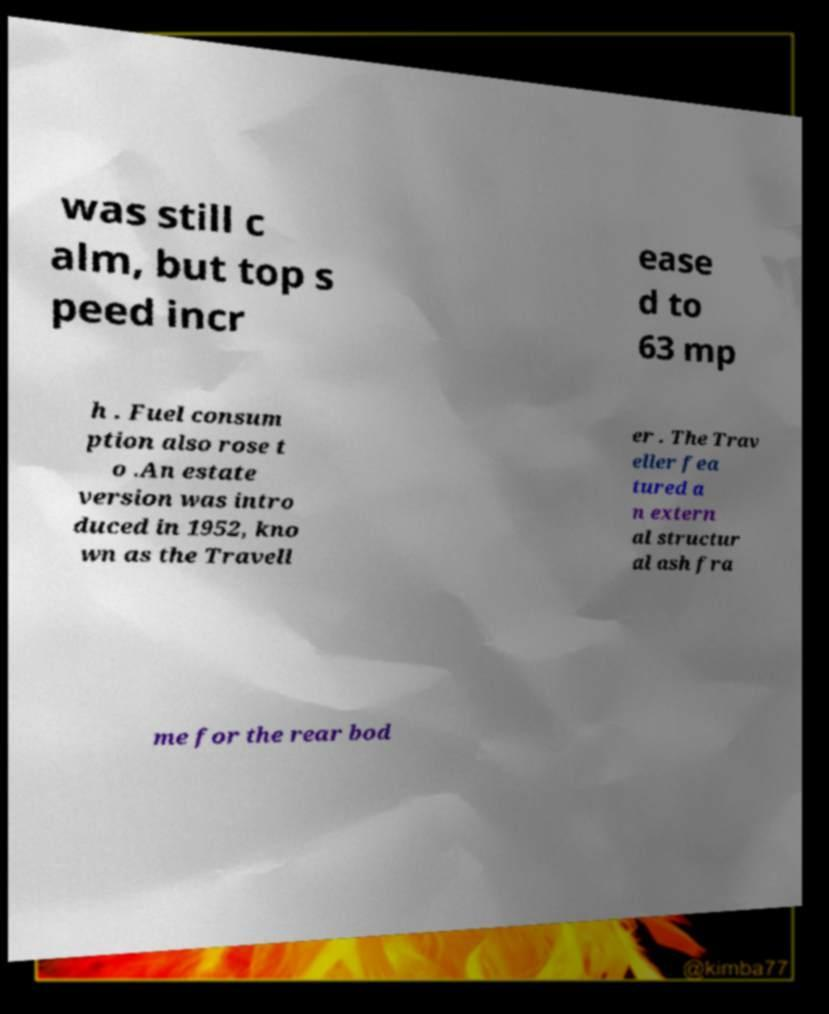Can you read and provide the text displayed in the image?This photo seems to have some interesting text. Can you extract and type it out for me? was still c alm, but top s peed incr ease d to 63 mp h . Fuel consum ption also rose t o .An estate version was intro duced in 1952, kno wn as the Travell er . The Trav eller fea tured a n extern al structur al ash fra me for the rear bod 